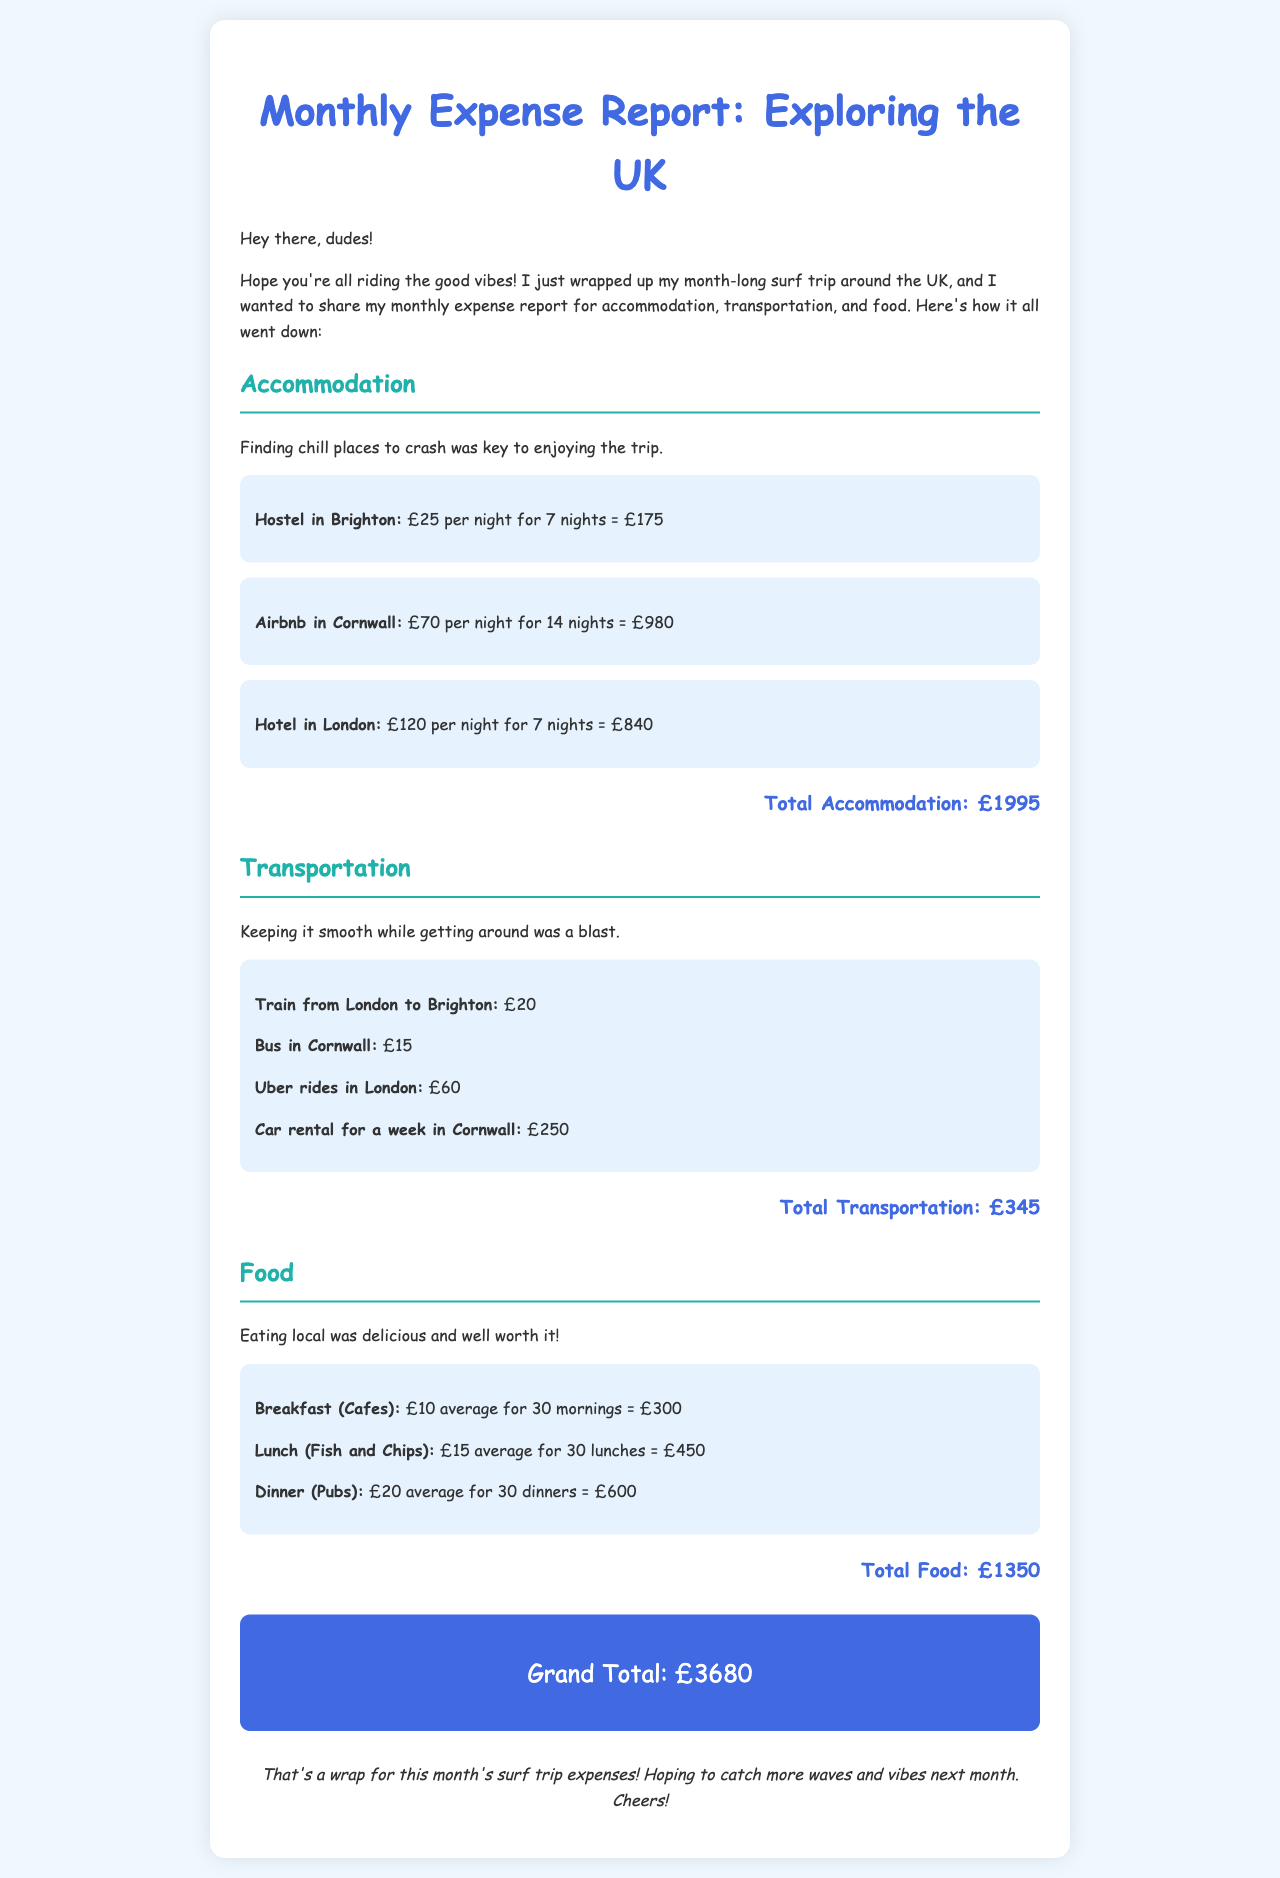What was the total accommodation cost? The total accommodation cost is compiled from the prices of hostels, Airbnbs, and hotels during the trip, which adds up to £1995.
Answer: £1995 What types of transportation expenses are listed? The transportation section details the costs of different modes of transport, including train, bus, Uber, and car rental, showcasing a variety of travel options.
Answer: Train, Bus, Uber, Car rental How many nights did the surfer stay in the Airbnb? The Airbnb stay in Cornwall was for a total of 14 nights, as explicitly stated in the accommodation section for that lodging.
Answer: 14 nights What is the average cost of lunch? The document states that the average cost of lunch (Fish and Chips) was £15, which is specifically mentioned in the food section.
Answer: £15 What is the grand total expenditure for the month? The grand total expenditure is the sum of accommodation, transportation, and food costs, calculated to be £3680 as noted in the document.
Answer: £3680 Which city had the most expensive accommodation? The hotel in London was the most expensive option listed for accommodation, at £120 per night, and this is clearly indicated in the expense report.
Answer: London What was the cost of the car rental for one week? The document lists the cost of car rental for a week in Cornwall as £250, which is directly stated in the transportation expenses.
Answer: £250 Which meal had the highest average cost? The highest average cost per meal was for dinner (Pubs) at £20, as detailed in the food section of the report.
Answer: £20 